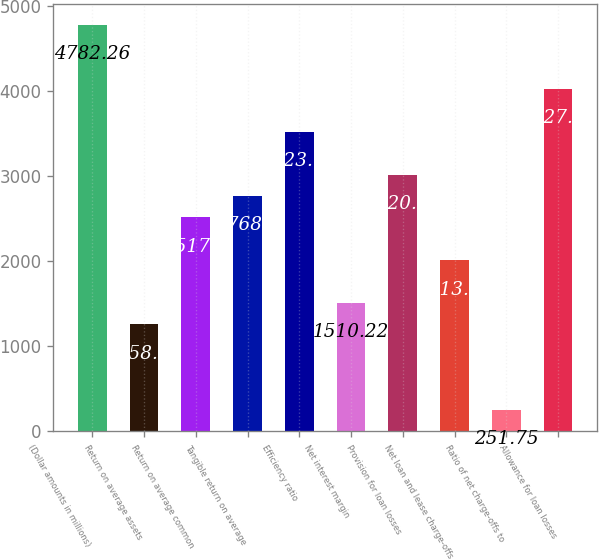<chart> <loc_0><loc_0><loc_500><loc_500><bar_chart><fcel>(Dollar amounts in millions)<fcel>Return on average assets<fcel>Return on average common<fcel>Tangible return on average<fcel>Efficiency ratio<fcel>Net interest margin<fcel>Provision for loan losses<fcel>Net loan and lease charge-offs<fcel>Ratio of net charge-offs to<fcel>Allowance for loan losses<nl><fcel>4782.26<fcel>1258.53<fcel>2517<fcel>2768.7<fcel>3523.79<fcel>1510.22<fcel>3020.39<fcel>2013.61<fcel>251.75<fcel>4027.18<nl></chart> 